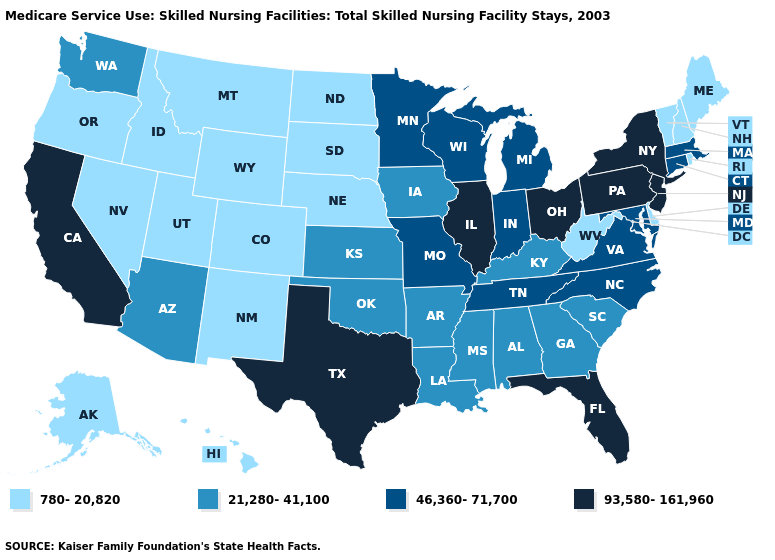Does California have the lowest value in the West?
Quick response, please. No. Name the states that have a value in the range 21,280-41,100?
Quick response, please. Alabama, Arizona, Arkansas, Georgia, Iowa, Kansas, Kentucky, Louisiana, Mississippi, Oklahoma, South Carolina, Washington. What is the value of North Carolina?
Write a very short answer. 46,360-71,700. Which states have the highest value in the USA?
Be succinct. California, Florida, Illinois, New Jersey, New York, Ohio, Pennsylvania, Texas. Which states have the lowest value in the South?
Concise answer only. Delaware, West Virginia. What is the lowest value in states that border Vermont?
Give a very brief answer. 780-20,820. Name the states that have a value in the range 21,280-41,100?
Give a very brief answer. Alabama, Arizona, Arkansas, Georgia, Iowa, Kansas, Kentucky, Louisiana, Mississippi, Oklahoma, South Carolina, Washington. Does Texas have the highest value in the USA?
Quick response, please. Yes. Among the states that border Wisconsin , which have the highest value?
Be succinct. Illinois. Which states hav the highest value in the MidWest?
Be succinct. Illinois, Ohio. Name the states that have a value in the range 46,360-71,700?
Be succinct. Connecticut, Indiana, Maryland, Massachusetts, Michigan, Minnesota, Missouri, North Carolina, Tennessee, Virginia, Wisconsin. Name the states that have a value in the range 780-20,820?
Give a very brief answer. Alaska, Colorado, Delaware, Hawaii, Idaho, Maine, Montana, Nebraska, Nevada, New Hampshire, New Mexico, North Dakota, Oregon, Rhode Island, South Dakota, Utah, Vermont, West Virginia, Wyoming. What is the value of Alabama?
Write a very short answer. 21,280-41,100. Which states have the highest value in the USA?
Quick response, please. California, Florida, Illinois, New Jersey, New York, Ohio, Pennsylvania, Texas. What is the highest value in the MidWest ?
Concise answer only. 93,580-161,960. 